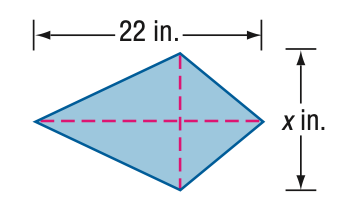Answer the mathemtical geometry problem and directly provide the correct option letter.
Question: Find x. A = 92 in^2.
Choices: A: 4.2 B: 6.3 C: 8.4 D: 10.5 C 